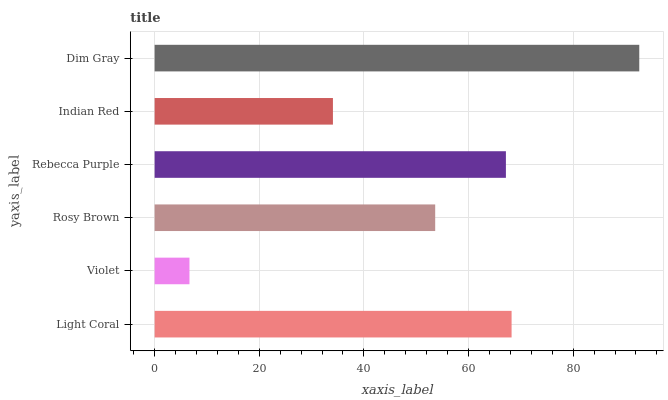Is Violet the minimum?
Answer yes or no. Yes. Is Dim Gray the maximum?
Answer yes or no. Yes. Is Rosy Brown the minimum?
Answer yes or no. No. Is Rosy Brown the maximum?
Answer yes or no. No. Is Rosy Brown greater than Violet?
Answer yes or no. Yes. Is Violet less than Rosy Brown?
Answer yes or no. Yes. Is Violet greater than Rosy Brown?
Answer yes or no. No. Is Rosy Brown less than Violet?
Answer yes or no. No. Is Rebecca Purple the high median?
Answer yes or no. Yes. Is Rosy Brown the low median?
Answer yes or no. Yes. Is Violet the high median?
Answer yes or no. No. Is Violet the low median?
Answer yes or no. No. 